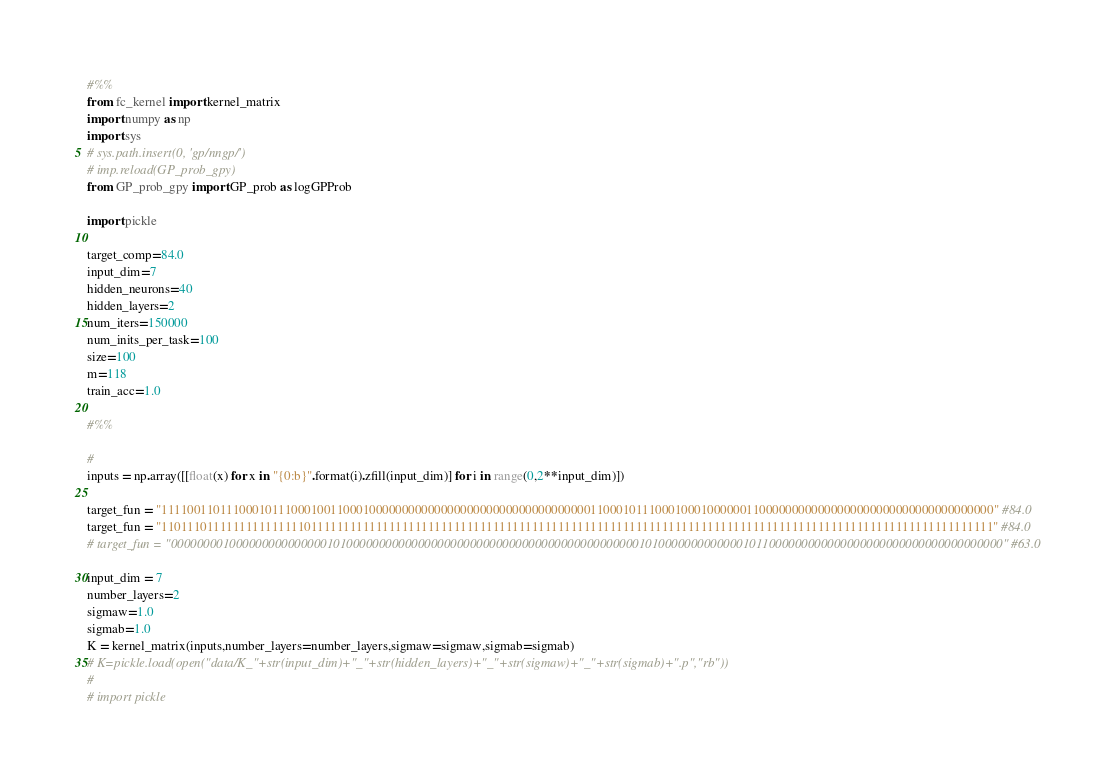<code> <loc_0><loc_0><loc_500><loc_500><_Python_>#%%
from fc_kernel import kernel_matrix
import numpy as np
import sys
# sys.path.insert(0, 'gp/nngp/')
# imp.reload(GP_prob_gpy)
from GP_prob_gpy import GP_prob as logGPProb

import pickle

target_comp=84.0
input_dim=7
hidden_neurons=40
hidden_layers=2
num_iters=150000
num_inits_per_task=100
size=100
m=118
train_acc=1.0

#%%

#
inputs = np.array([[float(x) for x in "{0:b}".format(i).zfill(input_dim)] for i in range(0,2**input_dim)])

target_fun = "11110011011100010111000100110001000000000000000000000000000000000011000101110001000100000011000000000000000000000000000000000000" #84.0
target_fun = "11011101111111111111110111111111111111111111111111111111111111111111111111111111111111111111111111111111111111111111111111111111" #84.0
# target_fun = "00000000100000000000000010100000000000000000000000000000000000000000000010100000000000001011000000000000000000000000000000000000" #63.0

input_dim = 7
number_layers=2
sigmaw=1.0
sigmab=1.0
K = kernel_matrix(inputs,number_layers=number_layers,sigmaw=sigmaw,sigmab=sigmab)
# K=pickle.load(open("data/K_"+str(input_dim)+"_"+str(hidden_layers)+"_"+str(sigmaw)+"_"+str(sigmab)+".p","rb"))
#
# import pickle</code> 